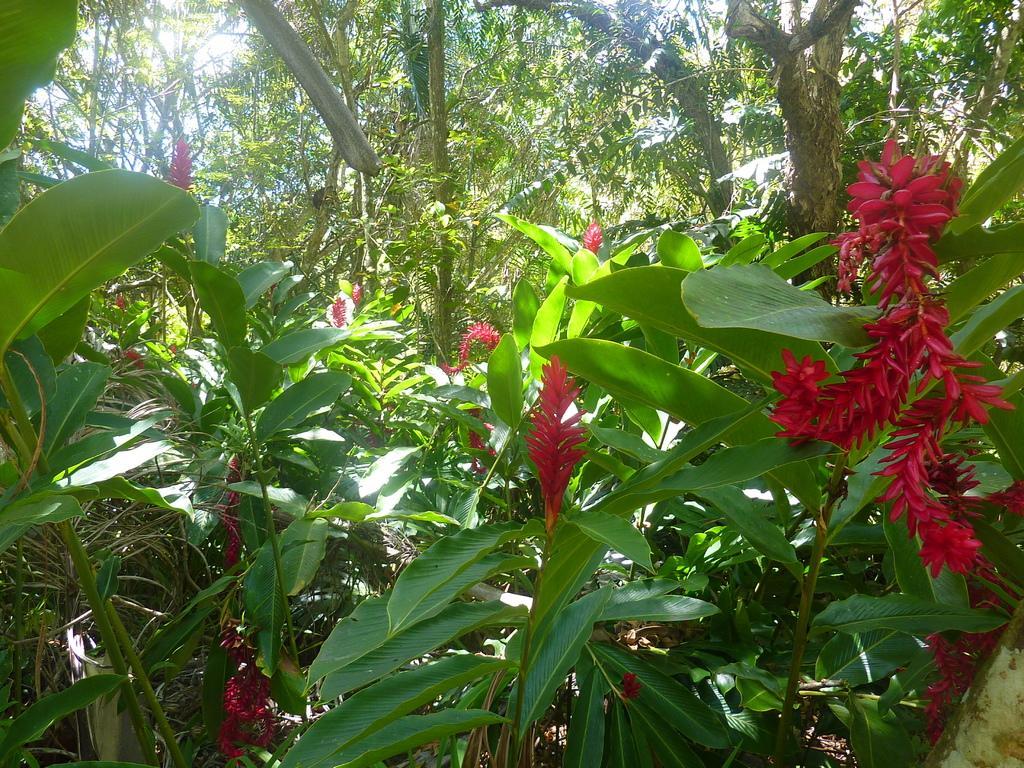In one or two sentences, can you explain what this image depicts? In this image, we can see some trees and plants. 